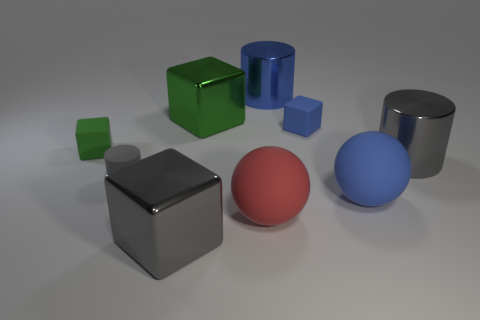What number of blocks are either large cyan matte objects or tiny blue things?
Your answer should be compact. 1. What is the color of the cylinder that is on the right side of the green shiny block and in front of the small blue thing?
Make the answer very short. Gray. Is there anything else that has the same color as the small cylinder?
Offer a terse response. Yes. There is a shiny cylinder to the left of the blue rubber thing in front of the small green cube; what color is it?
Keep it short and to the point. Blue. Do the red thing and the green shiny cube have the same size?
Make the answer very short. Yes. Is the big gray thing behind the big red matte object made of the same material as the large ball that is in front of the large blue matte sphere?
Offer a very short reply. No. What is the shape of the blue thing that is on the left side of the small matte block to the right of the big rubber ball on the left side of the blue shiny thing?
Your answer should be very brief. Cylinder. Is the number of big blue rubber spheres greater than the number of tiny matte things?
Your response must be concise. No. Is there a large green matte cylinder?
Your answer should be very brief. No. How many things are either gray cylinders on the left side of the big green thing or gray objects that are to the left of the gray shiny cylinder?
Offer a terse response. 2. 